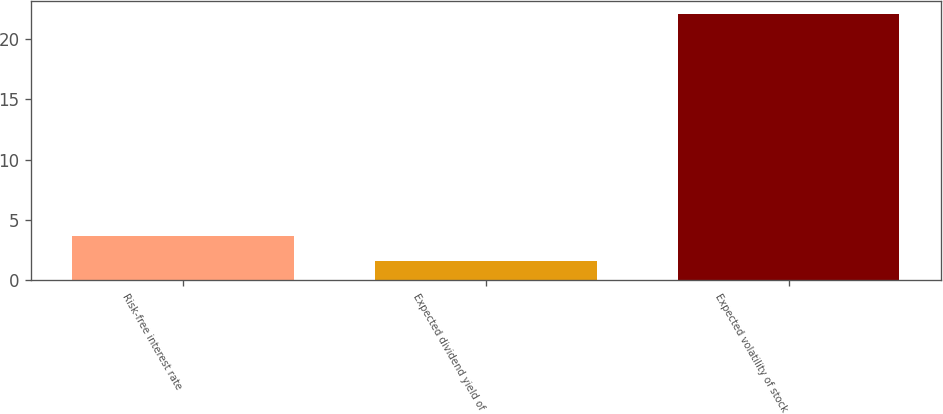Convert chart. <chart><loc_0><loc_0><loc_500><loc_500><bar_chart><fcel>Risk-free interest rate<fcel>Expected dividend yield of<fcel>Expected volatility of stock<nl><fcel>3.63<fcel>1.58<fcel>22.08<nl></chart> 